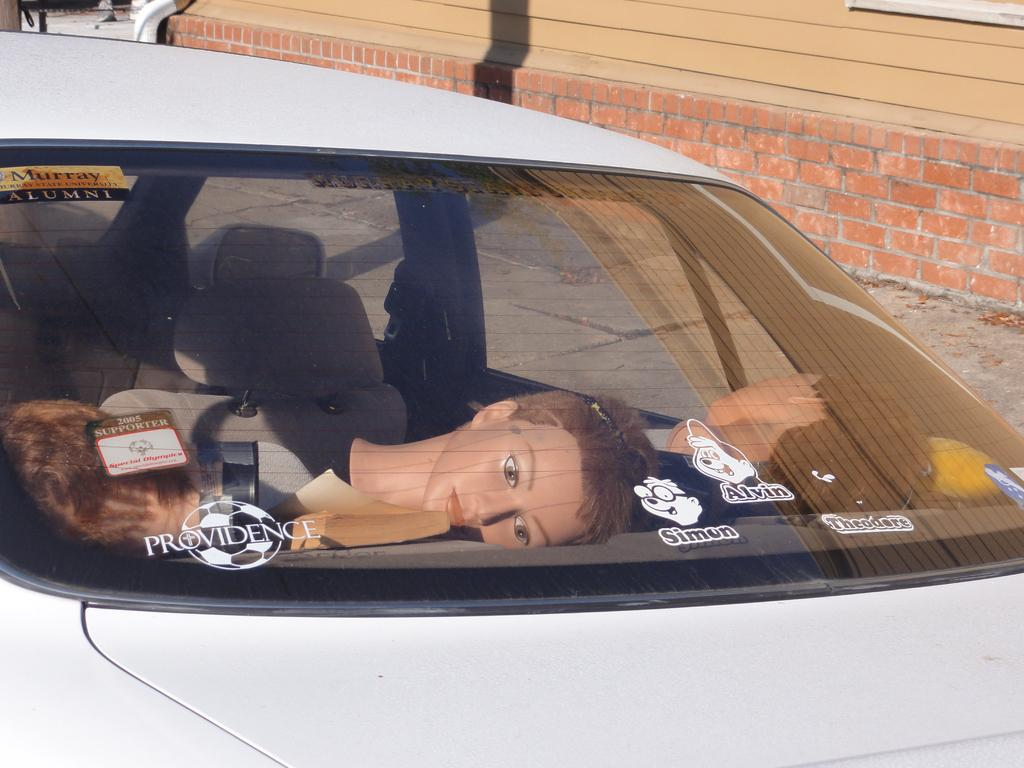What is the main subject of the image? The main subject of the image is a car. What is inside the car? There is a mannequin inside the car in the image. What can be seen in the background of the image? There is a building beside the car. What type of needle is the mannequin holding in the image? There is no needle present in the image; the mannequin is inside the car. What letters can be seen on the building in the image? The provided facts do not mention any letters on the building, so we cannot determine if any letters are present. 